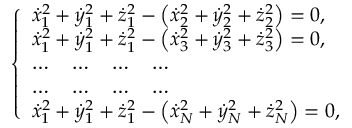Convert formula to latex. <formula><loc_0><loc_0><loc_500><loc_500>\left \{ \begin{array} { l } { { \dot { x } } _ { 1 } ^ { 2 } + { \dot { y } } _ { 1 } ^ { 2 } + { \dot { z } } _ { 1 } ^ { 2 } - \left ( { \dot { x } } _ { 2 } ^ { 2 } + { \dot { y } } _ { 2 } ^ { 2 } + { \dot { z } } _ { 2 } ^ { 2 } \right ) = 0 , } \\ { { \dot { x } } _ { 1 } ^ { 2 } + { \dot { y } } _ { 1 } ^ { 2 } + { \dot { z } } _ { 1 } ^ { 2 } - \left ( { \dot { x } } _ { 3 } ^ { 2 } + { \dot { y } } _ { 3 } ^ { 2 } + { \dot { z } } _ { 3 } ^ { 2 } \right ) = 0 , } \\ { \dots \quad \dots \quad \dots \quad \dots } \\ { \dots \quad \dots \quad \dots \quad \dots } \\ { { \dot { x } } _ { 1 } ^ { 2 } + { \dot { y } } _ { 1 } ^ { 2 } + { \dot { z } } _ { 1 } ^ { 2 } - \left ( { \dot { x } } _ { N } ^ { 2 } + { \dot { y } } _ { N } ^ { 2 } + { \dot { z } } _ { N } ^ { 2 } \right ) = 0 , } \end{array}</formula> 